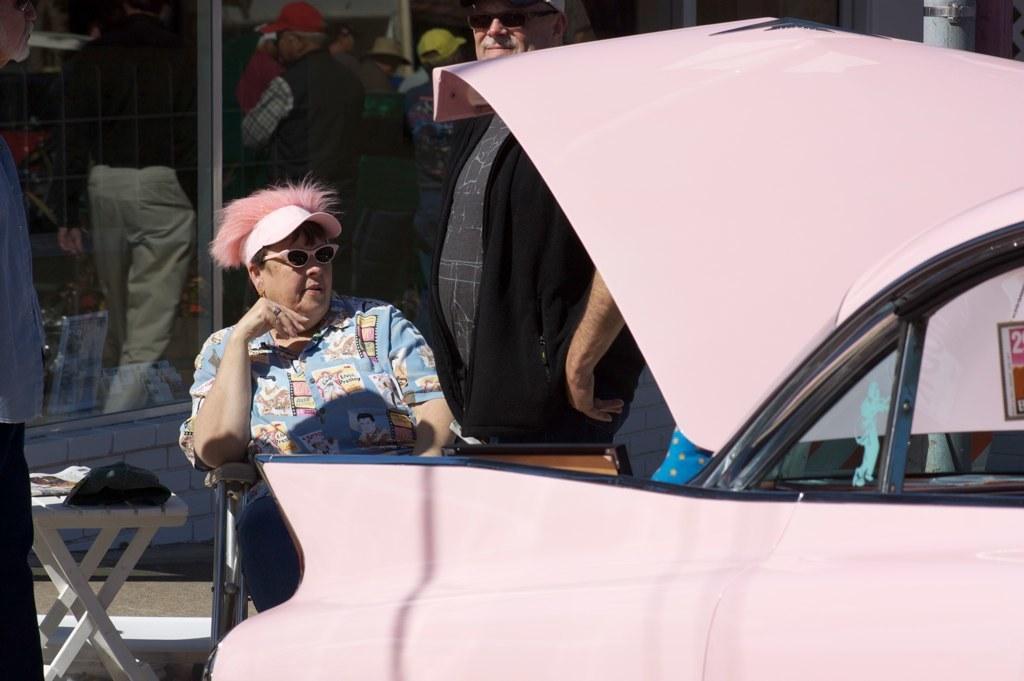Please provide a concise description of this image. In the image there is a person in blue t-shirt and pink cap sitting on chair behind a pink car and in the back there are many people standing. 